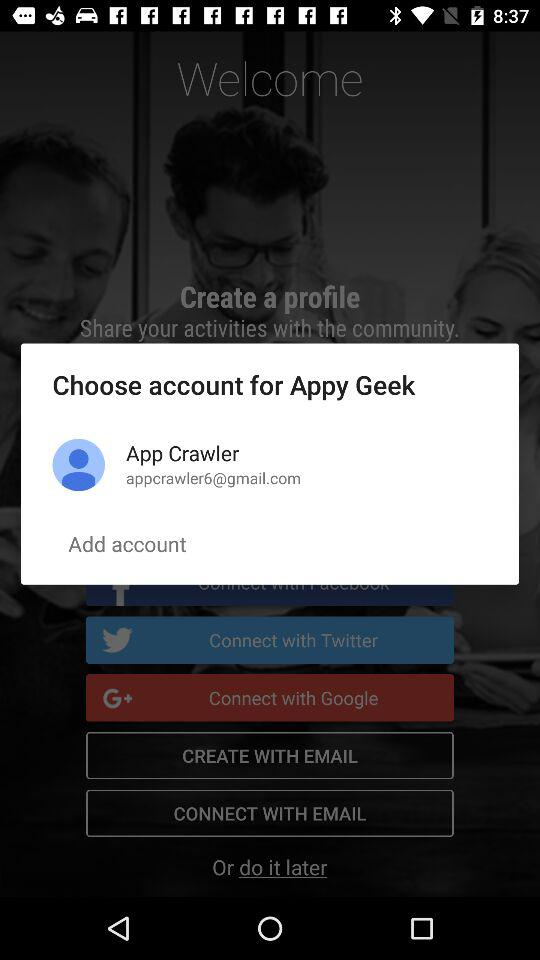What accounts can be used to create a profile? The accounts that can be used to create a profile are "Twitter", "Google" and "EMAIL". 